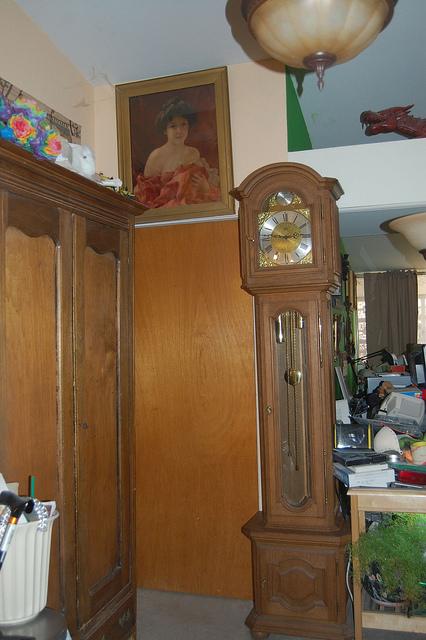Is the statue in the upper-right corner of a Chinese dragon?
Keep it brief. Yes. Is there  a picture above the door?
Write a very short answer. Yes. What is this type of clock called?
Concise answer only. Grandfather. 